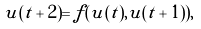<formula> <loc_0><loc_0><loc_500><loc_500>u ( t + 2 ) = f ( u ( t ) , u ( t + 1 ) ) ,</formula> 